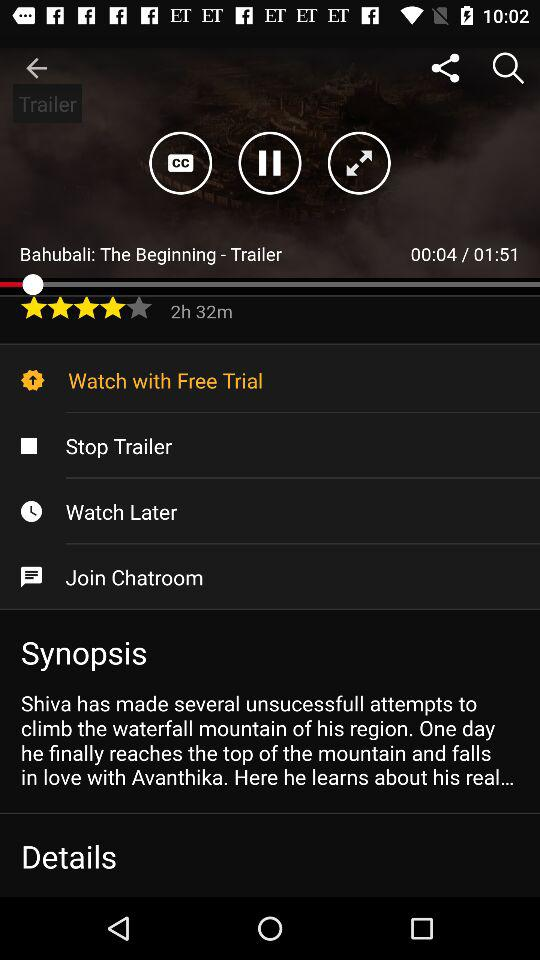What is the title of the movie trailer? The title of the movie trailer is Bahubali: The Beginning. 